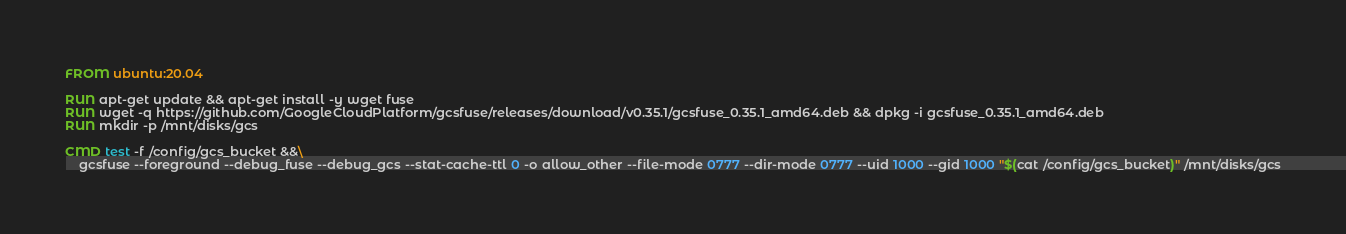<code> <loc_0><loc_0><loc_500><loc_500><_Dockerfile_>FROM ubuntu:20.04

RUN apt-get update && apt-get install -y wget fuse
RUN wget -q https://github.com/GoogleCloudPlatform/gcsfuse/releases/download/v0.35.1/gcsfuse_0.35.1_amd64.deb && dpkg -i gcsfuse_0.35.1_amd64.deb
RUN mkdir -p /mnt/disks/gcs

CMD test -f /config/gcs_bucket &&\
    gcsfuse --foreground --debug_fuse --debug_gcs --stat-cache-ttl 0 -o allow_other --file-mode 0777 --dir-mode 0777 --uid 1000 --gid 1000 "$(cat /config/gcs_bucket)" /mnt/disks/gcs
</code> 